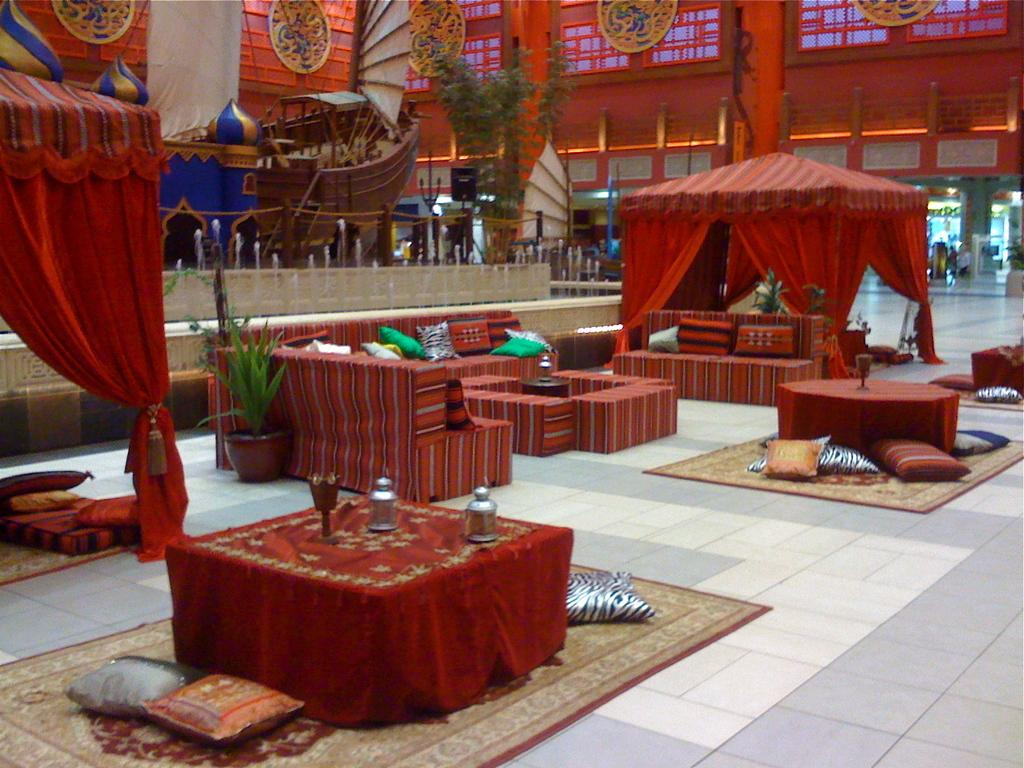What type of furniture is located in the middle of the picture? There are sofas and tables in the middle of the picture. What can be seen on the left side of the picture? There is a ship on the left side of the picture. What is visible in the background of the picture? There are plants and a wall in the background of the picture. What type of dolls are being offered in the aftermath of the shipwreck? There are no dolls or shipwreck depicted in the image. What type of offer is being made by the ship in the image? The image does not show any offers being made by the ship; it only shows the ship on the left side of the picture. 